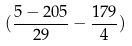Convert formula to latex. <formula><loc_0><loc_0><loc_500><loc_500>( \frac { 5 - 2 0 5 } { 2 9 } - \frac { 1 7 9 } { 4 } )</formula> 